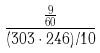Convert formula to latex. <formula><loc_0><loc_0><loc_500><loc_500>\frac { \frac { 9 } { 6 0 } } { ( 3 0 3 \cdot 2 4 6 ) / 1 0 }</formula> 